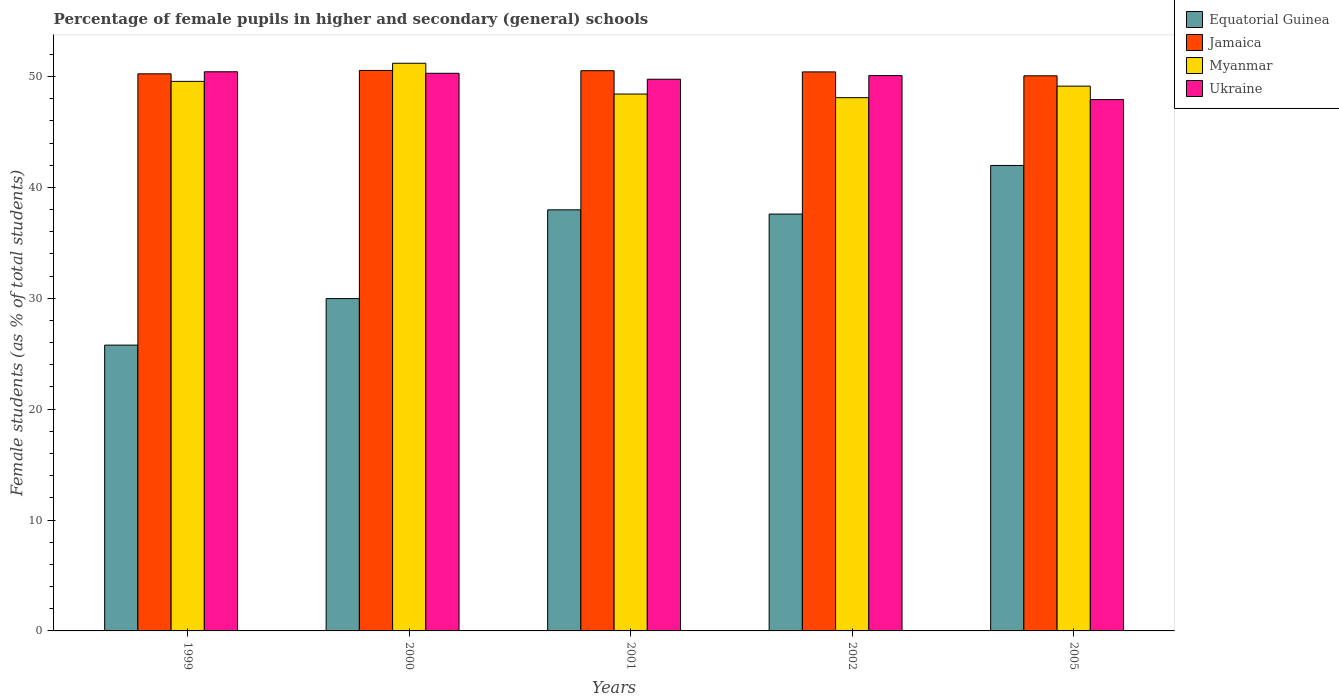How many groups of bars are there?
Provide a short and direct response. 5. Are the number of bars on each tick of the X-axis equal?
Keep it short and to the point. Yes. How many bars are there on the 2nd tick from the left?
Provide a short and direct response. 4. How many bars are there on the 4th tick from the right?
Provide a succinct answer. 4. What is the percentage of female pupils in higher and secondary schools in Myanmar in 2001?
Offer a terse response. 48.42. Across all years, what is the maximum percentage of female pupils in higher and secondary schools in Jamaica?
Keep it short and to the point. 50.54. Across all years, what is the minimum percentage of female pupils in higher and secondary schools in Jamaica?
Offer a terse response. 50.06. In which year was the percentage of female pupils in higher and secondary schools in Ukraine maximum?
Your answer should be compact. 1999. What is the total percentage of female pupils in higher and secondary schools in Jamaica in the graph?
Keep it short and to the point. 251.78. What is the difference between the percentage of female pupils in higher and secondary schools in Equatorial Guinea in 2001 and that in 2002?
Offer a terse response. 0.38. What is the difference between the percentage of female pupils in higher and secondary schools in Jamaica in 2001 and the percentage of female pupils in higher and secondary schools in Equatorial Guinea in 2002?
Your response must be concise. 12.93. What is the average percentage of female pupils in higher and secondary schools in Jamaica per year?
Provide a short and direct response. 50.36. In the year 2005, what is the difference between the percentage of female pupils in higher and secondary schools in Jamaica and percentage of female pupils in higher and secondary schools in Equatorial Guinea?
Offer a terse response. 8.09. In how many years, is the percentage of female pupils in higher and secondary schools in Myanmar greater than 6 %?
Give a very brief answer. 5. What is the ratio of the percentage of female pupils in higher and secondary schools in Jamaica in 2001 to that in 2002?
Give a very brief answer. 1. Is the difference between the percentage of female pupils in higher and secondary schools in Jamaica in 1999 and 2002 greater than the difference between the percentage of female pupils in higher and secondary schools in Equatorial Guinea in 1999 and 2002?
Your response must be concise. Yes. What is the difference between the highest and the second highest percentage of female pupils in higher and secondary schools in Myanmar?
Your answer should be very brief. 1.63. What is the difference between the highest and the lowest percentage of female pupils in higher and secondary schools in Jamaica?
Offer a very short reply. 0.48. In how many years, is the percentage of female pupils in higher and secondary schools in Equatorial Guinea greater than the average percentage of female pupils in higher and secondary schools in Equatorial Guinea taken over all years?
Provide a succinct answer. 3. Is the sum of the percentage of female pupils in higher and secondary schools in Equatorial Guinea in 2002 and 2005 greater than the maximum percentage of female pupils in higher and secondary schools in Ukraine across all years?
Your response must be concise. Yes. What does the 3rd bar from the left in 2000 represents?
Your answer should be compact. Myanmar. What does the 4th bar from the right in 2000 represents?
Offer a terse response. Equatorial Guinea. Is it the case that in every year, the sum of the percentage of female pupils in higher and secondary schools in Jamaica and percentage of female pupils in higher and secondary schools in Ukraine is greater than the percentage of female pupils in higher and secondary schools in Equatorial Guinea?
Your response must be concise. Yes. What is the difference between two consecutive major ticks on the Y-axis?
Your response must be concise. 10. Does the graph contain any zero values?
Provide a succinct answer. No. Does the graph contain grids?
Your answer should be very brief. No. Where does the legend appear in the graph?
Provide a short and direct response. Top right. What is the title of the graph?
Keep it short and to the point. Percentage of female pupils in higher and secondary (general) schools. What is the label or title of the X-axis?
Your answer should be very brief. Years. What is the label or title of the Y-axis?
Your answer should be compact. Female students (as % of total students). What is the Female students (as % of total students) in Equatorial Guinea in 1999?
Make the answer very short. 25.77. What is the Female students (as % of total students) of Jamaica in 1999?
Your answer should be compact. 50.24. What is the Female students (as % of total students) of Myanmar in 1999?
Keep it short and to the point. 49.56. What is the Female students (as % of total students) in Ukraine in 1999?
Provide a short and direct response. 50.42. What is the Female students (as % of total students) in Equatorial Guinea in 2000?
Make the answer very short. 29.97. What is the Female students (as % of total students) of Jamaica in 2000?
Give a very brief answer. 50.54. What is the Female students (as % of total students) of Myanmar in 2000?
Offer a terse response. 51.19. What is the Female students (as % of total students) in Ukraine in 2000?
Ensure brevity in your answer.  50.29. What is the Female students (as % of total students) in Equatorial Guinea in 2001?
Your response must be concise. 37.97. What is the Female students (as % of total students) in Jamaica in 2001?
Keep it short and to the point. 50.52. What is the Female students (as % of total students) of Myanmar in 2001?
Keep it short and to the point. 48.42. What is the Female students (as % of total students) of Ukraine in 2001?
Keep it short and to the point. 49.75. What is the Female students (as % of total students) of Equatorial Guinea in 2002?
Provide a short and direct response. 37.59. What is the Female students (as % of total students) of Jamaica in 2002?
Keep it short and to the point. 50.41. What is the Female students (as % of total students) in Myanmar in 2002?
Your answer should be very brief. 48.09. What is the Female students (as % of total students) of Ukraine in 2002?
Offer a terse response. 50.08. What is the Female students (as % of total students) in Equatorial Guinea in 2005?
Ensure brevity in your answer.  41.98. What is the Female students (as % of total students) of Jamaica in 2005?
Your answer should be very brief. 50.06. What is the Female students (as % of total students) of Myanmar in 2005?
Provide a short and direct response. 49.13. What is the Female students (as % of total students) in Ukraine in 2005?
Offer a very short reply. 47.91. Across all years, what is the maximum Female students (as % of total students) of Equatorial Guinea?
Your answer should be compact. 41.98. Across all years, what is the maximum Female students (as % of total students) of Jamaica?
Give a very brief answer. 50.54. Across all years, what is the maximum Female students (as % of total students) of Myanmar?
Make the answer very short. 51.19. Across all years, what is the maximum Female students (as % of total students) in Ukraine?
Ensure brevity in your answer.  50.42. Across all years, what is the minimum Female students (as % of total students) of Equatorial Guinea?
Make the answer very short. 25.77. Across all years, what is the minimum Female students (as % of total students) of Jamaica?
Give a very brief answer. 50.06. Across all years, what is the minimum Female students (as % of total students) in Myanmar?
Ensure brevity in your answer.  48.09. Across all years, what is the minimum Female students (as % of total students) in Ukraine?
Ensure brevity in your answer.  47.91. What is the total Female students (as % of total students) of Equatorial Guinea in the graph?
Provide a short and direct response. 173.29. What is the total Female students (as % of total students) of Jamaica in the graph?
Your answer should be compact. 251.78. What is the total Female students (as % of total students) of Myanmar in the graph?
Provide a short and direct response. 246.39. What is the total Female students (as % of total students) of Ukraine in the graph?
Offer a very short reply. 248.46. What is the difference between the Female students (as % of total students) of Equatorial Guinea in 1999 and that in 2000?
Make the answer very short. -4.2. What is the difference between the Female students (as % of total students) of Jamaica in 1999 and that in 2000?
Your answer should be compact. -0.3. What is the difference between the Female students (as % of total students) of Myanmar in 1999 and that in 2000?
Ensure brevity in your answer.  -1.63. What is the difference between the Female students (as % of total students) of Ukraine in 1999 and that in 2000?
Ensure brevity in your answer.  0.14. What is the difference between the Female students (as % of total students) of Equatorial Guinea in 1999 and that in 2001?
Offer a terse response. -12.2. What is the difference between the Female students (as % of total students) of Jamaica in 1999 and that in 2001?
Give a very brief answer. -0.28. What is the difference between the Female students (as % of total students) of Myanmar in 1999 and that in 2001?
Provide a short and direct response. 1.14. What is the difference between the Female students (as % of total students) in Ukraine in 1999 and that in 2001?
Give a very brief answer. 0.67. What is the difference between the Female students (as % of total students) of Equatorial Guinea in 1999 and that in 2002?
Keep it short and to the point. -11.82. What is the difference between the Female students (as % of total students) of Jamaica in 1999 and that in 2002?
Give a very brief answer. -0.17. What is the difference between the Female students (as % of total students) in Myanmar in 1999 and that in 2002?
Provide a succinct answer. 1.47. What is the difference between the Female students (as % of total students) of Ukraine in 1999 and that in 2002?
Your answer should be compact. 0.34. What is the difference between the Female students (as % of total students) of Equatorial Guinea in 1999 and that in 2005?
Your answer should be compact. -16.2. What is the difference between the Female students (as % of total students) of Jamaica in 1999 and that in 2005?
Make the answer very short. 0.18. What is the difference between the Female students (as % of total students) in Myanmar in 1999 and that in 2005?
Your answer should be compact. 0.43. What is the difference between the Female students (as % of total students) in Ukraine in 1999 and that in 2005?
Make the answer very short. 2.51. What is the difference between the Female students (as % of total students) of Equatorial Guinea in 2000 and that in 2001?
Your answer should be compact. -8. What is the difference between the Female students (as % of total students) of Jamaica in 2000 and that in 2001?
Make the answer very short. 0.02. What is the difference between the Female students (as % of total students) of Myanmar in 2000 and that in 2001?
Offer a very short reply. 2.78. What is the difference between the Female students (as % of total students) in Ukraine in 2000 and that in 2001?
Offer a very short reply. 0.54. What is the difference between the Female students (as % of total students) in Equatorial Guinea in 2000 and that in 2002?
Your answer should be very brief. -7.62. What is the difference between the Female students (as % of total students) in Jamaica in 2000 and that in 2002?
Make the answer very short. 0.13. What is the difference between the Female students (as % of total students) in Myanmar in 2000 and that in 2002?
Your answer should be compact. 3.1. What is the difference between the Female students (as % of total students) of Ukraine in 2000 and that in 2002?
Provide a succinct answer. 0.21. What is the difference between the Female students (as % of total students) in Equatorial Guinea in 2000 and that in 2005?
Keep it short and to the point. -12.01. What is the difference between the Female students (as % of total students) in Jamaica in 2000 and that in 2005?
Keep it short and to the point. 0.48. What is the difference between the Female students (as % of total students) in Myanmar in 2000 and that in 2005?
Keep it short and to the point. 2.06. What is the difference between the Female students (as % of total students) in Ukraine in 2000 and that in 2005?
Offer a very short reply. 2.37. What is the difference between the Female students (as % of total students) in Equatorial Guinea in 2001 and that in 2002?
Offer a very short reply. 0.38. What is the difference between the Female students (as % of total students) in Jamaica in 2001 and that in 2002?
Provide a succinct answer. 0.11. What is the difference between the Female students (as % of total students) of Myanmar in 2001 and that in 2002?
Give a very brief answer. 0.33. What is the difference between the Female students (as % of total students) of Ukraine in 2001 and that in 2002?
Provide a short and direct response. -0.33. What is the difference between the Female students (as % of total students) of Equatorial Guinea in 2001 and that in 2005?
Offer a terse response. -4. What is the difference between the Female students (as % of total students) in Jamaica in 2001 and that in 2005?
Give a very brief answer. 0.46. What is the difference between the Female students (as % of total students) in Myanmar in 2001 and that in 2005?
Make the answer very short. -0.71. What is the difference between the Female students (as % of total students) in Ukraine in 2001 and that in 2005?
Your answer should be very brief. 1.84. What is the difference between the Female students (as % of total students) of Equatorial Guinea in 2002 and that in 2005?
Offer a very short reply. -4.38. What is the difference between the Female students (as % of total students) of Jamaica in 2002 and that in 2005?
Keep it short and to the point. 0.35. What is the difference between the Female students (as % of total students) in Myanmar in 2002 and that in 2005?
Your answer should be very brief. -1.04. What is the difference between the Female students (as % of total students) of Ukraine in 2002 and that in 2005?
Provide a short and direct response. 2.17. What is the difference between the Female students (as % of total students) of Equatorial Guinea in 1999 and the Female students (as % of total students) of Jamaica in 2000?
Offer a terse response. -24.77. What is the difference between the Female students (as % of total students) in Equatorial Guinea in 1999 and the Female students (as % of total students) in Myanmar in 2000?
Your answer should be compact. -25.42. What is the difference between the Female students (as % of total students) of Equatorial Guinea in 1999 and the Female students (as % of total students) of Ukraine in 2000?
Make the answer very short. -24.51. What is the difference between the Female students (as % of total students) in Jamaica in 1999 and the Female students (as % of total students) in Myanmar in 2000?
Make the answer very short. -0.95. What is the difference between the Female students (as % of total students) in Jamaica in 1999 and the Female students (as % of total students) in Ukraine in 2000?
Your response must be concise. -0.05. What is the difference between the Female students (as % of total students) in Myanmar in 1999 and the Female students (as % of total students) in Ukraine in 2000?
Make the answer very short. -0.73. What is the difference between the Female students (as % of total students) of Equatorial Guinea in 1999 and the Female students (as % of total students) of Jamaica in 2001?
Provide a succinct answer. -24.75. What is the difference between the Female students (as % of total students) of Equatorial Guinea in 1999 and the Female students (as % of total students) of Myanmar in 2001?
Keep it short and to the point. -22.64. What is the difference between the Female students (as % of total students) of Equatorial Guinea in 1999 and the Female students (as % of total students) of Ukraine in 2001?
Offer a terse response. -23.98. What is the difference between the Female students (as % of total students) in Jamaica in 1999 and the Female students (as % of total students) in Myanmar in 2001?
Keep it short and to the point. 1.82. What is the difference between the Female students (as % of total students) in Jamaica in 1999 and the Female students (as % of total students) in Ukraine in 2001?
Provide a short and direct response. 0.49. What is the difference between the Female students (as % of total students) of Myanmar in 1999 and the Female students (as % of total students) of Ukraine in 2001?
Your answer should be very brief. -0.19. What is the difference between the Female students (as % of total students) of Equatorial Guinea in 1999 and the Female students (as % of total students) of Jamaica in 2002?
Offer a very short reply. -24.64. What is the difference between the Female students (as % of total students) in Equatorial Guinea in 1999 and the Female students (as % of total students) in Myanmar in 2002?
Your answer should be compact. -22.32. What is the difference between the Female students (as % of total students) of Equatorial Guinea in 1999 and the Female students (as % of total students) of Ukraine in 2002?
Offer a terse response. -24.31. What is the difference between the Female students (as % of total students) in Jamaica in 1999 and the Female students (as % of total students) in Myanmar in 2002?
Your answer should be compact. 2.15. What is the difference between the Female students (as % of total students) of Jamaica in 1999 and the Female students (as % of total students) of Ukraine in 2002?
Ensure brevity in your answer.  0.16. What is the difference between the Female students (as % of total students) of Myanmar in 1999 and the Female students (as % of total students) of Ukraine in 2002?
Give a very brief answer. -0.52. What is the difference between the Female students (as % of total students) of Equatorial Guinea in 1999 and the Female students (as % of total students) of Jamaica in 2005?
Make the answer very short. -24.29. What is the difference between the Female students (as % of total students) in Equatorial Guinea in 1999 and the Female students (as % of total students) in Myanmar in 2005?
Provide a short and direct response. -23.35. What is the difference between the Female students (as % of total students) of Equatorial Guinea in 1999 and the Female students (as % of total students) of Ukraine in 2005?
Provide a short and direct response. -22.14. What is the difference between the Female students (as % of total students) in Jamaica in 1999 and the Female students (as % of total students) in Myanmar in 2005?
Provide a succinct answer. 1.11. What is the difference between the Female students (as % of total students) in Jamaica in 1999 and the Female students (as % of total students) in Ukraine in 2005?
Your answer should be very brief. 2.33. What is the difference between the Female students (as % of total students) in Myanmar in 1999 and the Female students (as % of total students) in Ukraine in 2005?
Ensure brevity in your answer.  1.65. What is the difference between the Female students (as % of total students) in Equatorial Guinea in 2000 and the Female students (as % of total students) in Jamaica in 2001?
Give a very brief answer. -20.55. What is the difference between the Female students (as % of total students) in Equatorial Guinea in 2000 and the Female students (as % of total students) in Myanmar in 2001?
Your response must be concise. -18.45. What is the difference between the Female students (as % of total students) in Equatorial Guinea in 2000 and the Female students (as % of total students) in Ukraine in 2001?
Your response must be concise. -19.78. What is the difference between the Female students (as % of total students) in Jamaica in 2000 and the Female students (as % of total students) in Myanmar in 2001?
Give a very brief answer. 2.13. What is the difference between the Female students (as % of total students) in Jamaica in 2000 and the Female students (as % of total students) in Ukraine in 2001?
Offer a very short reply. 0.79. What is the difference between the Female students (as % of total students) of Myanmar in 2000 and the Female students (as % of total students) of Ukraine in 2001?
Offer a terse response. 1.44. What is the difference between the Female students (as % of total students) in Equatorial Guinea in 2000 and the Female students (as % of total students) in Jamaica in 2002?
Provide a short and direct response. -20.44. What is the difference between the Female students (as % of total students) of Equatorial Guinea in 2000 and the Female students (as % of total students) of Myanmar in 2002?
Your response must be concise. -18.12. What is the difference between the Female students (as % of total students) of Equatorial Guinea in 2000 and the Female students (as % of total students) of Ukraine in 2002?
Keep it short and to the point. -20.11. What is the difference between the Female students (as % of total students) in Jamaica in 2000 and the Female students (as % of total students) in Myanmar in 2002?
Make the answer very short. 2.45. What is the difference between the Female students (as % of total students) of Jamaica in 2000 and the Female students (as % of total students) of Ukraine in 2002?
Make the answer very short. 0.46. What is the difference between the Female students (as % of total students) in Myanmar in 2000 and the Female students (as % of total students) in Ukraine in 2002?
Make the answer very short. 1.11. What is the difference between the Female students (as % of total students) of Equatorial Guinea in 2000 and the Female students (as % of total students) of Jamaica in 2005?
Your answer should be compact. -20.09. What is the difference between the Female students (as % of total students) of Equatorial Guinea in 2000 and the Female students (as % of total students) of Myanmar in 2005?
Keep it short and to the point. -19.16. What is the difference between the Female students (as % of total students) in Equatorial Guinea in 2000 and the Female students (as % of total students) in Ukraine in 2005?
Your answer should be compact. -17.95. What is the difference between the Female students (as % of total students) of Jamaica in 2000 and the Female students (as % of total students) of Myanmar in 2005?
Give a very brief answer. 1.42. What is the difference between the Female students (as % of total students) of Jamaica in 2000 and the Female students (as % of total students) of Ukraine in 2005?
Your answer should be compact. 2.63. What is the difference between the Female students (as % of total students) in Myanmar in 2000 and the Female students (as % of total students) in Ukraine in 2005?
Offer a terse response. 3.28. What is the difference between the Female students (as % of total students) in Equatorial Guinea in 2001 and the Female students (as % of total students) in Jamaica in 2002?
Provide a succinct answer. -12.44. What is the difference between the Female students (as % of total students) of Equatorial Guinea in 2001 and the Female students (as % of total students) of Myanmar in 2002?
Ensure brevity in your answer.  -10.12. What is the difference between the Female students (as % of total students) of Equatorial Guinea in 2001 and the Female students (as % of total students) of Ukraine in 2002?
Your response must be concise. -12.11. What is the difference between the Female students (as % of total students) of Jamaica in 2001 and the Female students (as % of total students) of Myanmar in 2002?
Ensure brevity in your answer.  2.43. What is the difference between the Female students (as % of total students) in Jamaica in 2001 and the Female students (as % of total students) in Ukraine in 2002?
Your answer should be compact. 0.44. What is the difference between the Female students (as % of total students) of Myanmar in 2001 and the Female students (as % of total students) of Ukraine in 2002?
Make the answer very short. -1.67. What is the difference between the Female students (as % of total students) in Equatorial Guinea in 2001 and the Female students (as % of total students) in Jamaica in 2005?
Make the answer very short. -12.09. What is the difference between the Female students (as % of total students) of Equatorial Guinea in 2001 and the Female students (as % of total students) of Myanmar in 2005?
Provide a succinct answer. -11.16. What is the difference between the Female students (as % of total students) in Equatorial Guinea in 2001 and the Female students (as % of total students) in Ukraine in 2005?
Provide a succinct answer. -9.94. What is the difference between the Female students (as % of total students) of Jamaica in 2001 and the Female students (as % of total students) of Myanmar in 2005?
Your response must be concise. 1.39. What is the difference between the Female students (as % of total students) in Jamaica in 2001 and the Female students (as % of total students) in Ukraine in 2005?
Ensure brevity in your answer.  2.61. What is the difference between the Female students (as % of total students) in Myanmar in 2001 and the Female students (as % of total students) in Ukraine in 2005?
Ensure brevity in your answer.  0.5. What is the difference between the Female students (as % of total students) in Equatorial Guinea in 2002 and the Female students (as % of total students) in Jamaica in 2005?
Your answer should be very brief. -12.47. What is the difference between the Female students (as % of total students) of Equatorial Guinea in 2002 and the Female students (as % of total students) of Myanmar in 2005?
Provide a succinct answer. -11.54. What is the difference between the Female students (as % of total students) in Equatorial Guinea in 2002 and the Female students (as % of total students) in Ukraine in 2005?
Offer a terse response. -10.32. What is the difference between the Female students (as % of total students) of Jamaica in 2002 and the Female students (as % of total students) of Myanmar in 2005?
Give a very brief answer. 1.28. What is the difference between the Female students (as % of total students) in Jamaica in 2002 and the Female students (as % of total students) in Ukraine in 2005?
Your answer should be compact. 2.5. What is the difference between the Female students (as % of total students) in Myanmar in 2002 and the Female students (as % of total students) in Ukraine in 2005?
Ensure brevity in your answer.  0.18. What is the average Female students (as % of total students) in Equatorial Guinea per year?
Offer a very short reply. 34.66. What is the average Female students (as % of total students) in Jamaica per year?
Ensure brevity in your answer.  50.36. What is the average Female students (as % of total students) of Myanmar per year?
Keep it short and to the point. 49.28. What is the average Female students (as % of total students) in Ukraine per year?
Give a very brief answer. 49.69. In the year 1999, what is the difference between the Female students (as % of total students) of Equatorial Guinea and Female students (as % of total students) of Jamaica?
Give a very brief answer. -24.47. In the year 1999, what is the difference between the Female students (as % of total students) in Equatorial Guinea and Female students (as % of total students) in Myanmar?
Your response must be concise. -23.79. In the year 1999, what is the difference between the Female students (as % of total students) in Equatorial Guinea and Female students (as % of total students) in Ukraine?
Offer a very short reply. -24.65. In the year 1999, what is the difference between the Female students (as % of total students) of Jamaica and Female students (as % of total students) of Myanmar?
Keep it short and to the point. 0.68. In the year 1999, what is the difference between the Female students (as % of total students) in Jamaica and Female students (as % of total students) in Ukraine?
Make the answer very short. -0.18. In the year 1999, what is the difference between the Female students (as % of total students) in Myanmar and Female students (as % of total students) in Ukraine?
Offer a very short reply. -0.86. In the year 2000, what is the difference between the Female students (as % of total students) in Equatorial Guinea and Female students (as % of total students) in Jamaica?
Your answer should be compact. -20.57. In the year 2000, what is the difference between the Female students (as % of total students) in Equatorial Guinea and Female students (as % of total students) in Myanmar?
Keep it short and to the point. -21.22. In the year 2000, what is the difference between the Female students (as % of total students) in Equatorial Guinea and Female students (as % of total students) in Ukraine?
Offer a terse response. -20.32. In the year 2000, what is the difference between the Female students (as % of total students) in Jamaica and Female students (as % of total students) in Myanmar?
Keep it short and to the point. -0.65. In the year 2000, what is the difference between the Female students (as % of total students) of Jamaica and Female students (as % of total students) of Ukraine?
Keep it short and to the point. 0.26. In the year 2000, what is the difference between the Female students (as % of total students) of Myanmar and Female students (as % of total students) of Ukraine?
Offer a terse response. 0.91. In the year 2001, what is the difference between the Female students (as % of total students) of Equatorial Guinea and Female students (as % of total students) of Jamaica?
Your answer should be very brief. -12.55. In the year 2001, what is the difference between the Female students (as % of total students) of Equatorial Guinea and Female students (as % of total students) of Myanmar?
Your answer should be very brief. -10.44. In the year 2001, what is the difference between the Female students (as % of total students) in Equatorial Guinea and Female students (as % of total students) in Ukraine?
Keep it short and to the point. -11.78. In the year 2001, what is the difference between the Female students (as % of total students) in Jamaica and Female students (as % of total students) in Myanmar?
Offer a terse response. 2.11. In the year 2001, what is the difference between the Female students (as % of total students) in Jamaica and Female students (as % of total students) in Ukraine?
Your response must be concise. 0.77. In the year 2001, what is the difference between the Female students (as % of total students) in Myanmar and Female students (as % of total students) in Ukraine?
Your answer should be compact. -1.34. In the year 2002, what is the difference between the Female students (as % of total students) of Equatorial Guinea and Female students (as % of total students) of Jamaica?
Your response must be concise. -12.82. In the year 2002, what is the difference between the Female students (as % of total students) of Equatorial Guinea and Female students (as % of total students) of Myanmar?
Make the answer very short. -10.5. In the year 2002, what is the difference between the Female students (as % of total students) of Equatorial Guinea and Female students (as % of total students) of Ukraine?
Provide a short and direct response. -12.49. In the year 2002, what is the difference between the Female students (as % of total students) of Jamaica and Female students (as % of total students) of Myanmar?
Provide a short and direct response. 2.32. In the year 2002, what is the difference between the Female students (as % of total students) in Jamaica and Female students (as % of total students) in Ukraine?
Your answer should be compact. 0.33. In the year 2002, what is the difference between the Female students (as % of total students) in Myanmar and Female students (as % of total students) in Ukraine?
Make the answer very short. -1.99. In the year 2005, what is the difference between the Female students (as % of total students) in Equatorial Guinea and Female students (as % of total students) in Jamaica?
Your answer should be compact. -8.09. In the year 2005, what is the difference between the Female students (as % of total students) in Equatorial Guinea and Female students (as % of total students) in Myanmar?
Your response must be concise. -7.15. In the year 2005, what is the difference between the Female students (as % of total students) in Equatorial Guinea and Female students (as % of total students) in Ukraine?
Provide a succinct answer. -5.94. In the year 2005, what is the difference between the Female students (as % of total students) in Jamaica and Female students (as % of total students) in Myanmar?
Your response must be concise. 0.93. In the year 2005, what is the difference between the Female students (as % of total students) in Jamaica and Female students (as % of total students) in Ukraine?
Make the answer very short. 2.15. In the year 2005, what is the difference between the Female students (as % of total students) in Myanmar and Female students (as % of total students) in Ukraine?
Ensure brevity in your answer.  1.21. What is the ratio of the Female students (as % of total students) in Equatorial Guinea in 1999 to that in 2000?
Your response must be concise. 0.86. What is the ratio of the Female students (as % of total students) in Myanmar in 1999 to that in 2000?
Keep it short and to the point. 0.97. What is the ratio of the Female students (as % of total students) in Ukraine in 1999 to that in 2000?
Keep it short and to the point. 1. What is the ratio of the Female students (as % of total students) in Equatorial Guinea in 1999 to that in 2001?
Ensure brevity in your answer.  0.68. What is the ratio of the Female students (as % of total students) of Myanmar in 1999 to that in 2001?
Your answer should be compact. 1.02. What is the ratio of the Female students (as % of total students) of Ukraine in 1999 to that in 2001?
Your response must be concise. 1.01. What is the ratio of the Female students (as % of total students) of Equatorial Guinea in 1999 to that in 2002?
Keep it short and to the point. 0.69. What is the ratio of the Female students (as % of total students) of Jamaica in 1999 to that in 2002?
Your answer should be compact. 1. What is the ratio of the Female students (as % of total students) in Myanmar in 1999 to that in 2002?
Offer a very short reply. 1.03. What is the ratio of the Female students (as % of total students) in Ukraine in 1999 to that in 2002?
Make the answer very short. 1.01. What is the ratio of the Female students (as % of total students) in Equatorial Guinea in 1999 to that in 2005?
Provide a succinct answer. 0.61. What is the ratio of the Female students (as % of total students) in Jamaica in 1999 to that in 2005?
Your answer should be compact. 1. What is the ratio of the Female students (as % of total students) of Myanmar in 1999 to that in 2005?
Your answer should be compact. 1.01. What is the ratio of the Female students (as % of total students) in Ukraine in 1999 to that in 2005?
Provide a short and direct response. 1.05. What is the ratio of the Female students (as % of total students) in Equatorial Guinea in 2000 to that in 2001?
Give a very brief answer. 0.79. What is the ratio of the Female students (as % of total students) in Jamaica in 2000 to that in 2001?
Offer a terse response. 1. What is the ratio of the Female students (as % of total students) in Myanmar in 2000 to that in 2001?
Your response must be concise. 1.06. What is the ratio of the Female students (as % of total students) in Ukraine in 2000 to that in 2001?
Ensure brevity in your answer.  1.01. What is the ratio of the Female students (as % of total students) of Equatorial Guinea in 2000 to that in 2002?
Keep it short and to the point. 0.8. What is the ratio of the Female students (as % of total students) in Myanmar in 2000 to that in 2002?
Offer a terse response. 1.06. What is the ratio of the Female students (as % of total students) of Equatorial Guinea in 2000 to that in 2005?
Keep it short and to the point. 0.71. What is the ratio of the Female students (as % of total students) of Jamaica in 2000 to that in 2005?
Provide a short and direct response. 1.01. What is the ratio of the Female students (as % of total students) of Myanmar in 2000 to that in 2005?
Give a very brief answer. 1.04. What is the ratio of the Female students (as % of total students) of Ukraine in 2000 to that in 2005?
Offer a terse response. 1.05. What is the ratio of the Female students (as % of total students) of Jamaica in 2001 to that in 2002?
Your response must be concise. 1. What is the ratio of the Female students (as % of total students) of Myanmar in 2001 to that in 2002?
Give a very brief answer. 1.01. What is the ratio of the Female students (as % of total students) in Equatorial Guinea in 2001 to that in 2005?
Provide a succinct answer. 0.9. What is the ratio of the Female students (as % of total students) in Jamaica in 2001 to that in 2005?
Offer a very short reply. 1.01. What is the ratio of the Female students (as % of total students) in Myanmar in 2001 to that in 2005?
Offer a terse response. 0.99. What is the ratio of the Female students (as % of total students) of Ukraine in 2001 to that in 2005?
Your answer should be compact. 1.04. What is the ratio of the Female students (as % of total students) of Equatorial Guinea in 2002 to that in 2005?
Provide a succinct answer. 0.9. What is the ratio of the Female students (as % of total students) of Myanmar in 2002 to that in 2005?
Keep it short and to the point. 0.98. What is the ratio of the Female students (as % of total students) in Ukraine in 2002 to that in 2005?
Your answer should be very brief. 1.05. What is the difference between the highest and the second highest Female students (as % of total students) in Equatorial Guinea?
Give a very brief answer. 4. What is the difference between the highest and the second highest Female students (as % of total students) of Jamaica?
Your answer should be compact. 0.02. What is the difference between the highest and the second highest Female students (as % of total students) of Myanmar?
Make the answer very short. 1.63. What is the difference between the highest and the second highest Female students (as % of total students) of Ukraine?
Provide a short and direct response. 0.14. What is the difference between the highest and the lowest Female students (as % of total students) of Equatorial Guinea?
Your answer should be very brief. 16.2. What is the difference between the highest and the lowest Female students (as % of total students) of Jamaica?
Your answer should be very brief. 0.48. What is the difference between the highest and the lowest Female students (as % of total students) in Myanmar?
Offer a very short reply. 3.1. What is the difference between the highest and the lowest Female students (as % of total students) of Ukraine?
Provide a short and direct response. 2.51. 